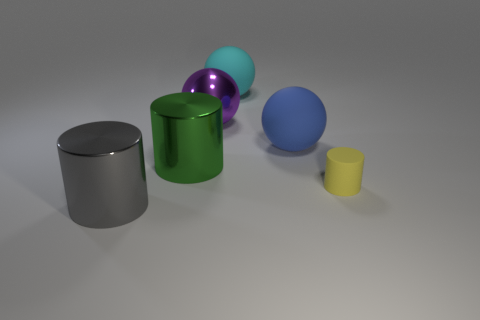Add 4 tiny blue cylinders. How many objects exist? 10 Subtract all large green cylinders. Subtract all purple metal objects. How many objects are left? 4 Add 4 large green metal things. How many large green metal things are left? 5 Add 6 blue matte cylinders. How many blue matte cylinders exist? 6 Subtract 1 green cylinders. How many objects are left? 5 